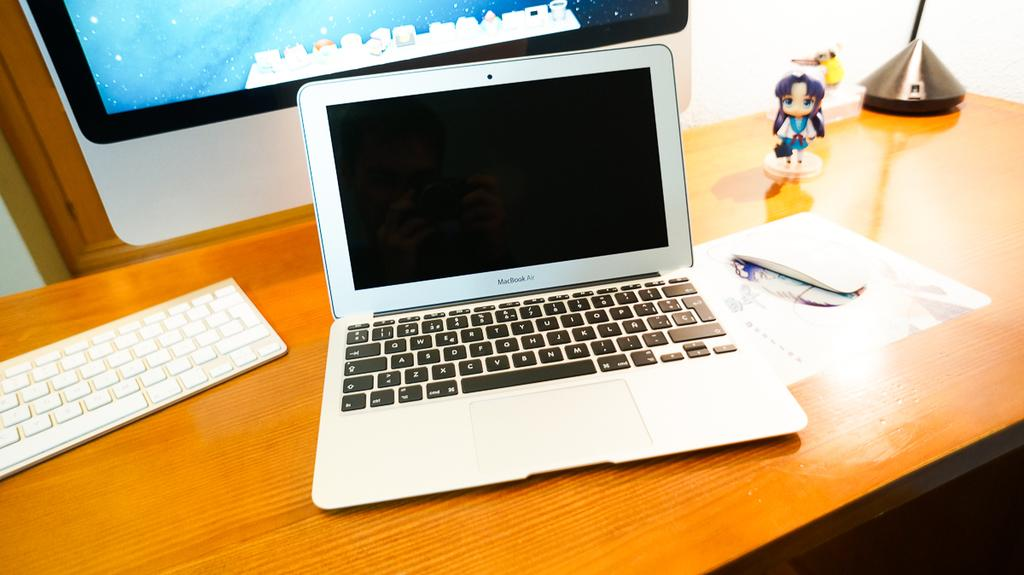<image>
Write a terse but informative summary of the picture. An open Macbook Air sits on brown desk. 